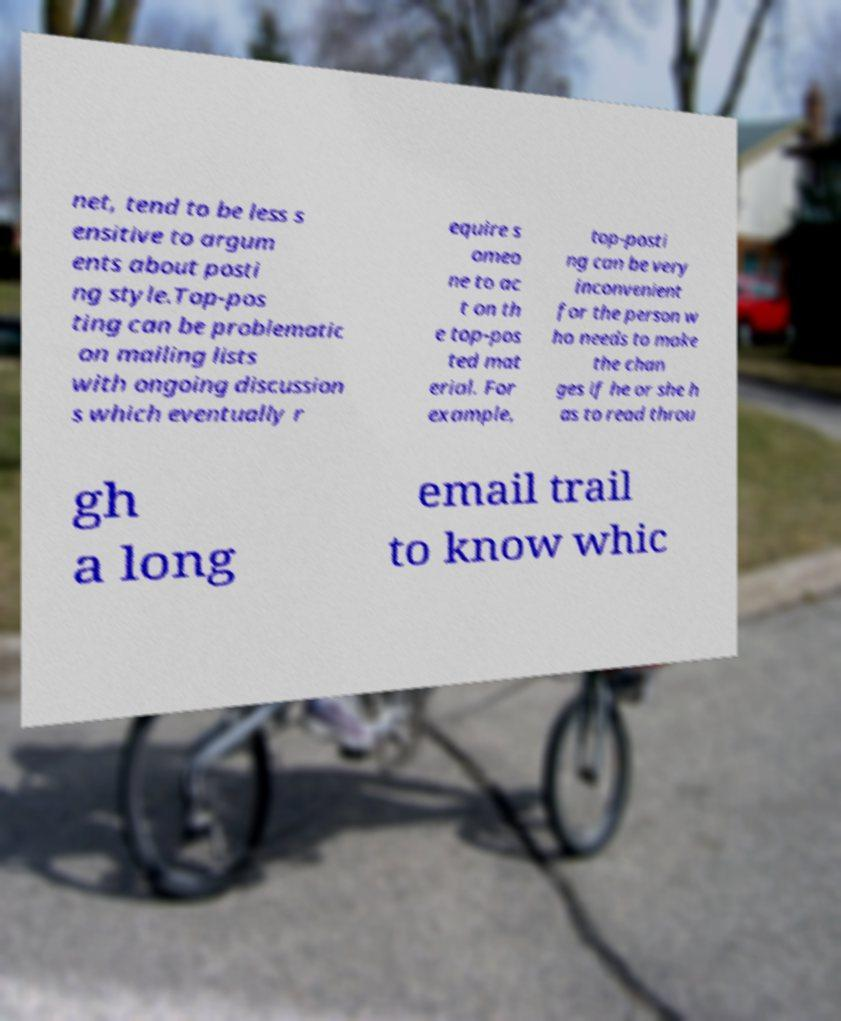I need the written content from this picture converted into text. Can you do that? net, tend to be less s ensitive to argum ents about posti ng style.Top-pos ting can be problematic on mailing lists with ongoing discussion s which eventually r equire s omeo ne to ac t on th e top-pos ted mat erial. For example, top-posti ng can be very inconvenient for the person w ho needs to make the chan ges if he or she h as to read throu gh a long email trail to know whic 